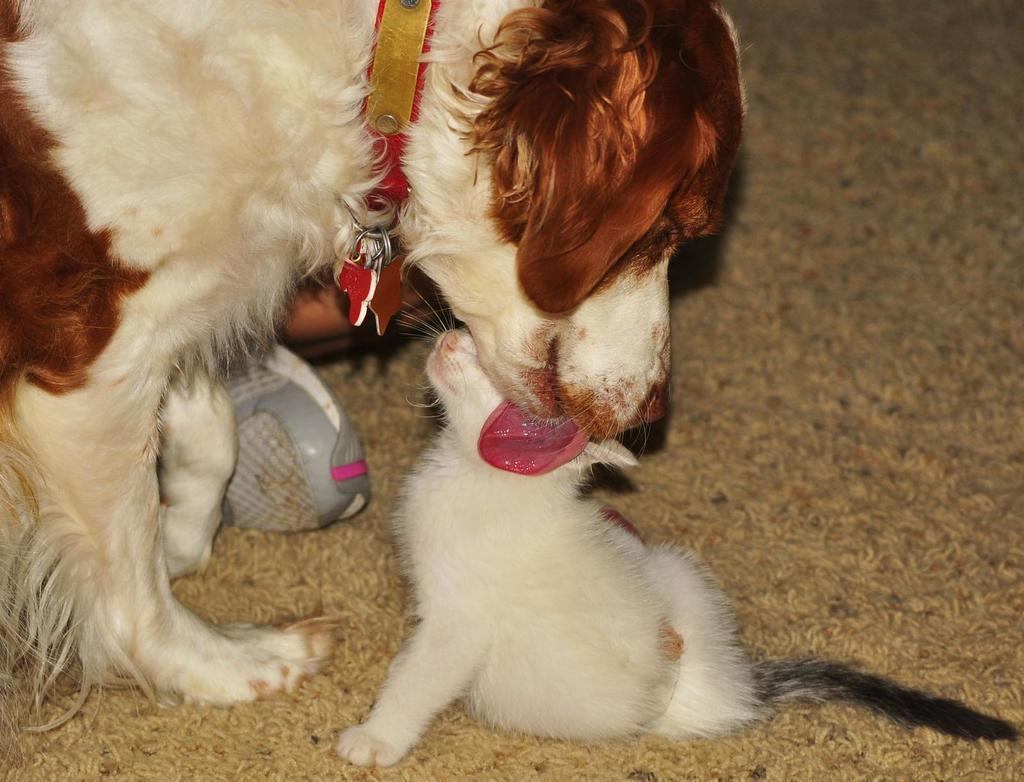What type of animals are present in the image? There is a dog and a cat in the image. Where are the animals located? Both animals are on a carpet. What is the size of the minute hand in the image? There is no minute hand present in the image; it features a dog and a cat on a carpet. 